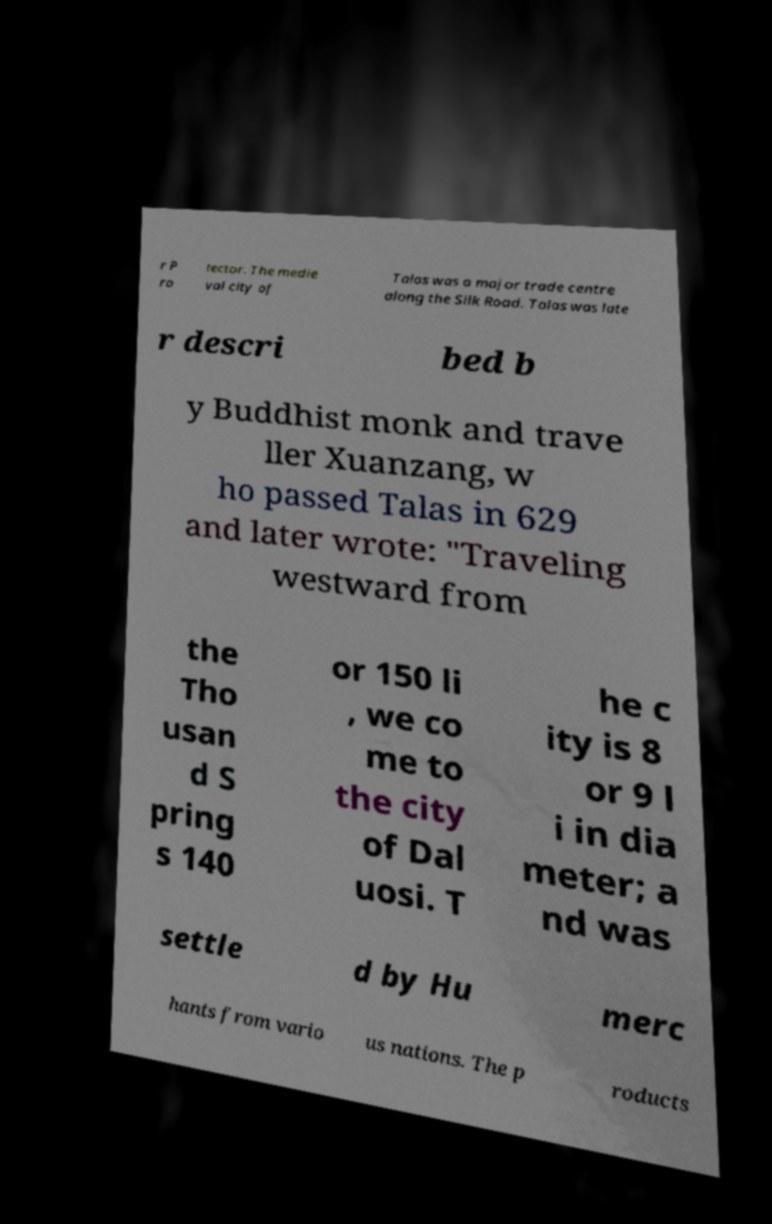Please identify and transcribe the text found in this image. r P ro tector. The medie val city of Talas was a major trade centre along the Silk Road. Talas was late r descri bed b y Buddhist monk and trave ller Xuanzang, w ho passed Talas in 629 and later wrote: "Traveling westward from the Tho usan d S pring s 140 or 150 li , we co me to the city of Dal uosi. T he c ity is 8 or 9 l i in dia meter; a nd was settle d by Hu merc hants from vario us nations. The p roducts 